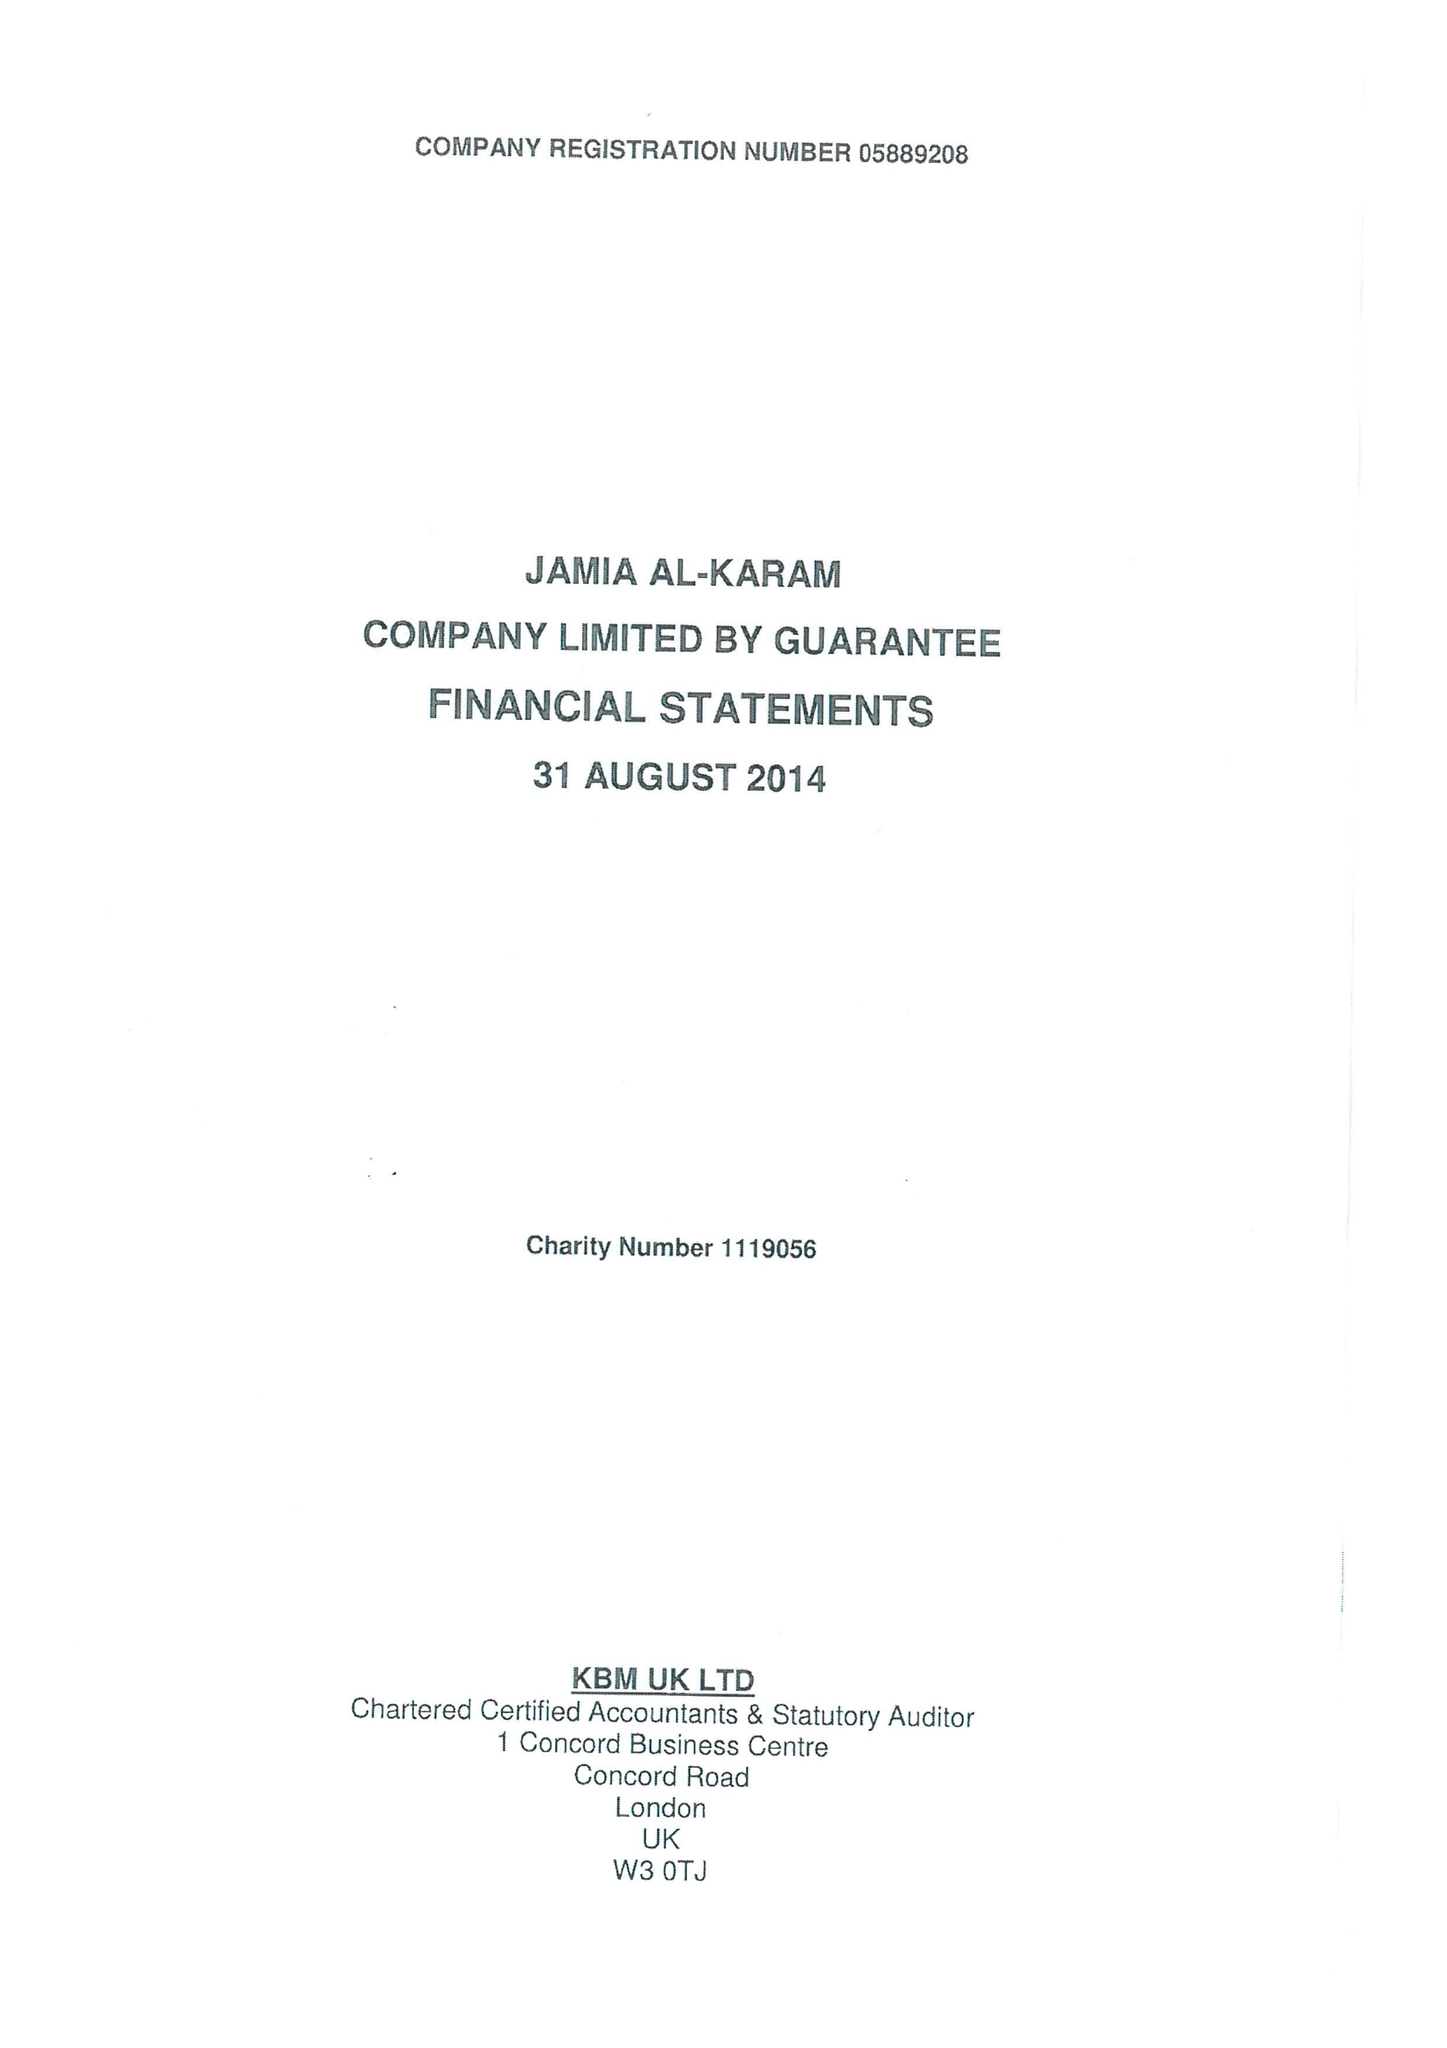What is the value for the income_annually_in_british_pounds?
Answer the question using a single word or phrase. 846544.00 